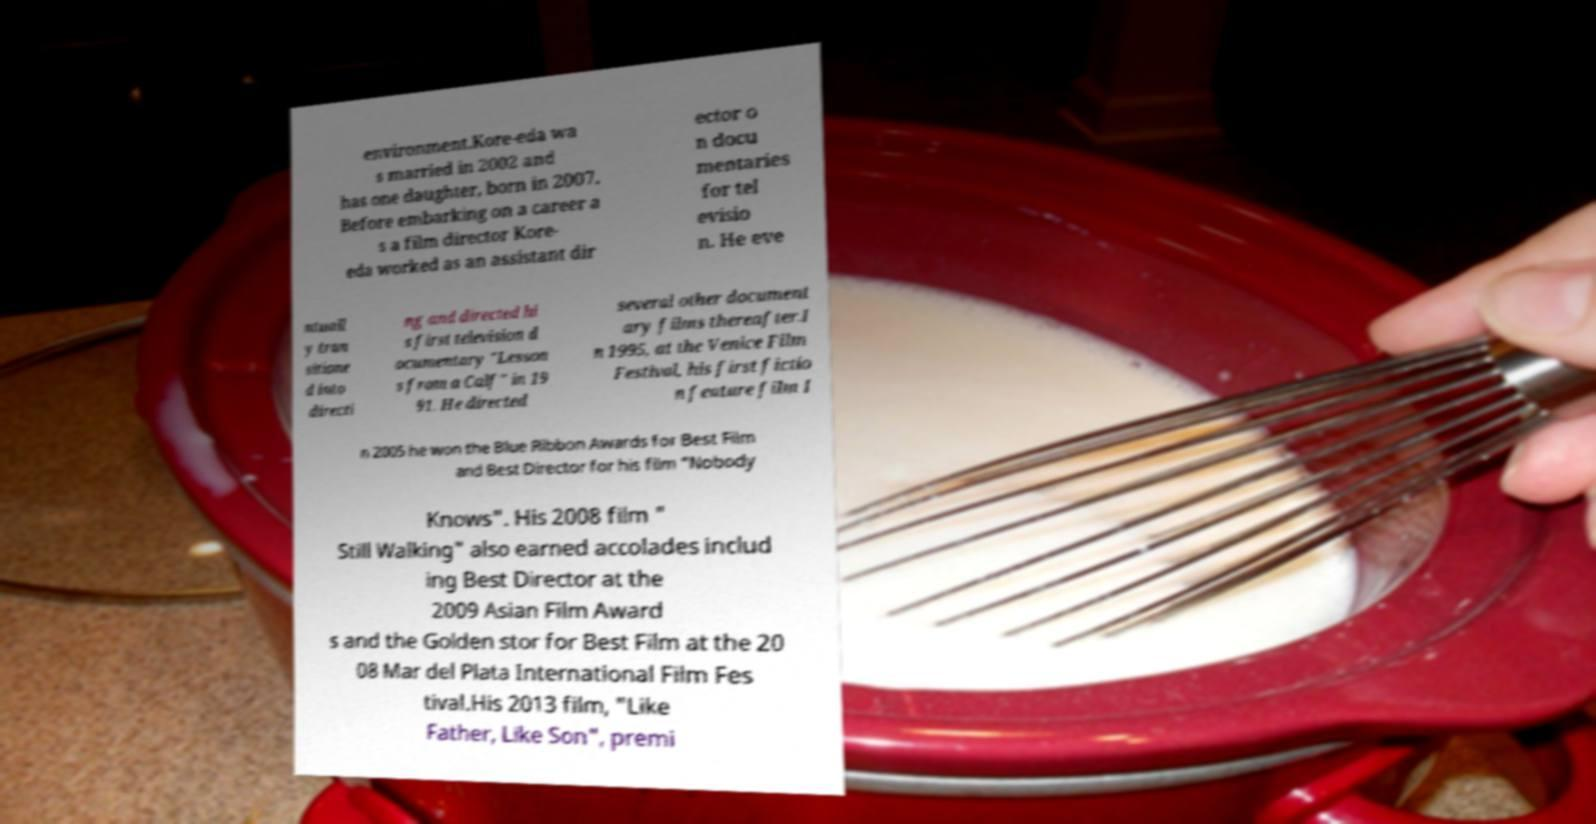I need the written content from this picture converted into text. Can you do that? environment.Kore-eda wa s married in 2002 and has one daughter, born in 2007. Before embarking on a career a s a film director Kore- eda worked as an assistant dir ector o n docu mentaries for tel evisio n. He eve ntuall y tran sitione d into directi ng and directed hi s first television d ocumentary "Lesson s from a Calf" in 19 91. He directed several other document ary films thereafter.I n 1995, at the Venice Film Festival, his first fictio n feature film I n 2005 he won the Blue Ribbon Awards for Best Film and Best Director for his film "Nobody Knows". His 2008 film " Still Walking" also earned accolades includ ing Best Director at the 2009 Asian Film Award s and the Golden stor for Best Film at the 20 08 Mar del Plata International Film Fes tival.His 2013 film, "Like Father, Like Son", premi 